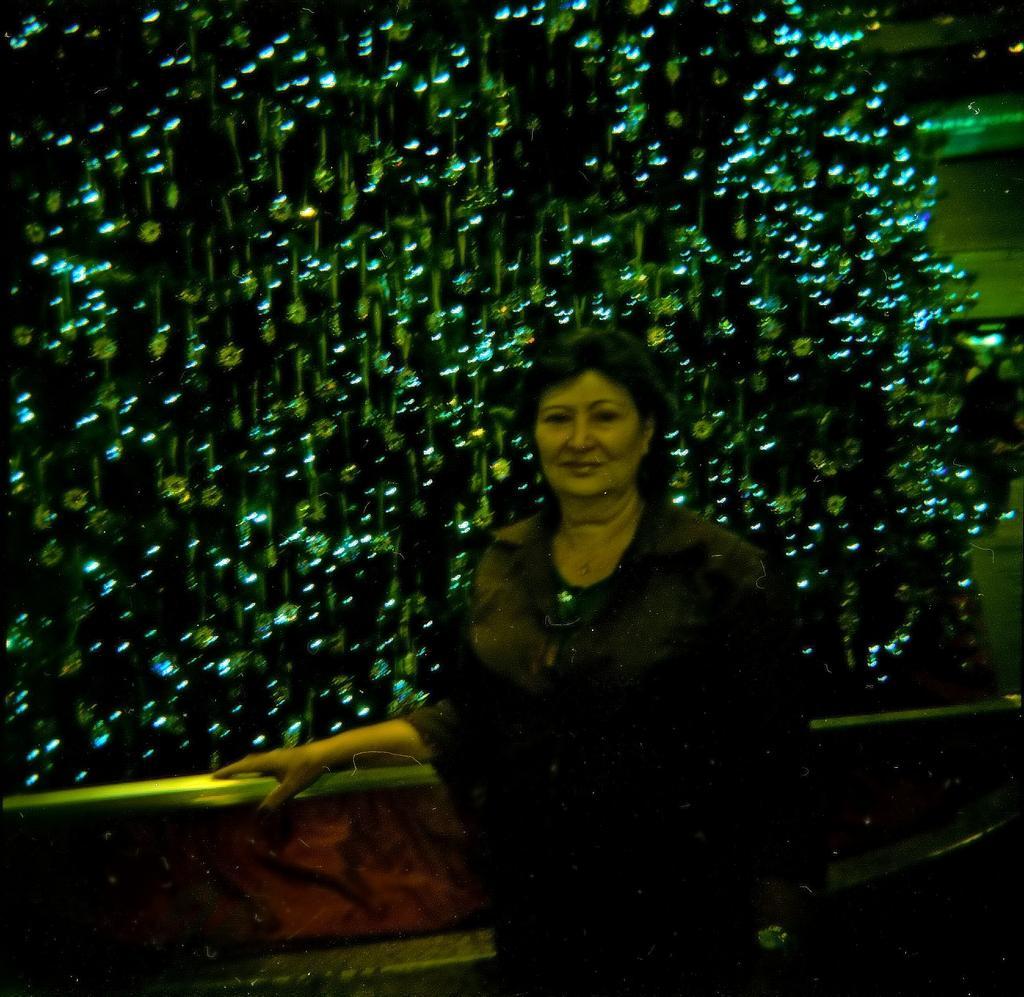Could you give a brief overview of what you see in this image? In this image in the center there is one woman standing, and in the background there are some lights and some poles and wall. 